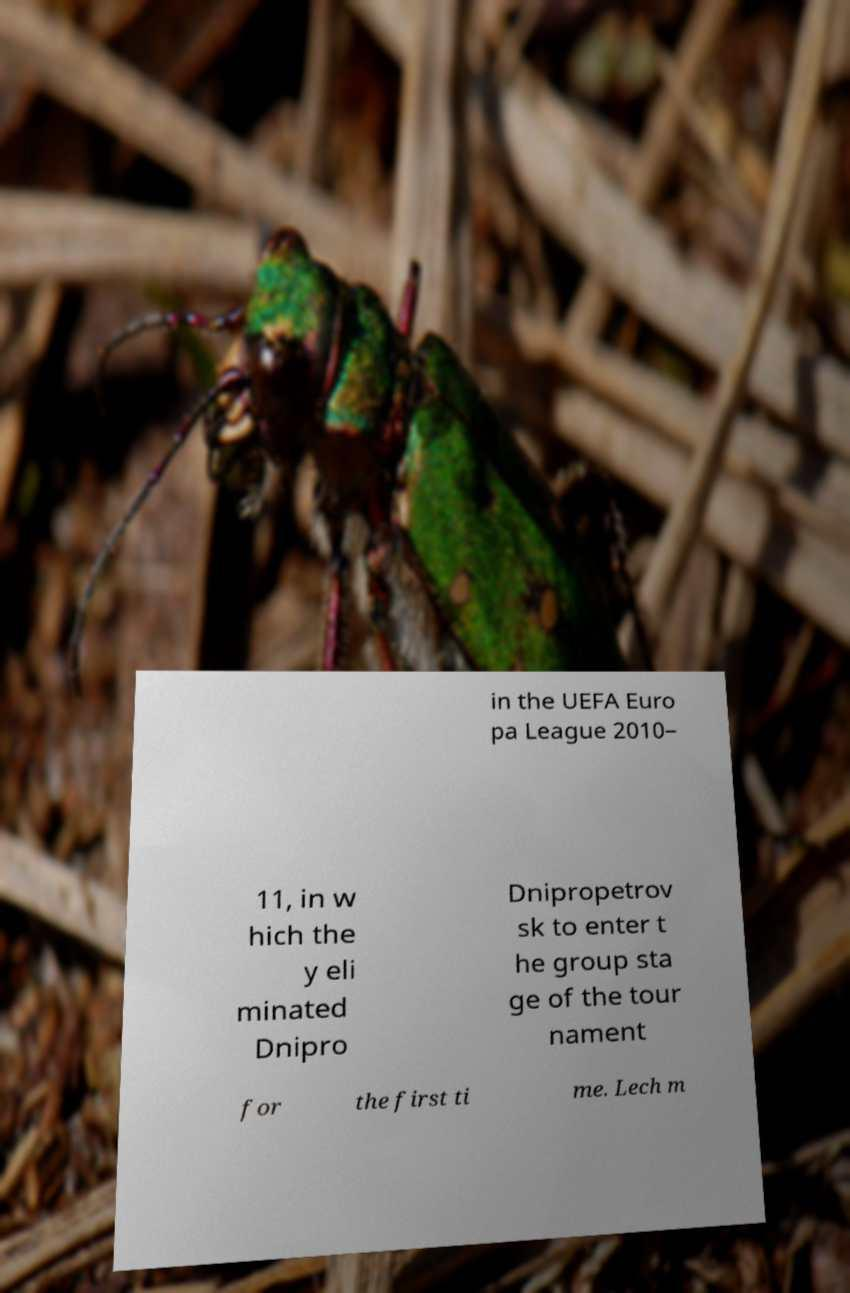Can you accurately transcribe the text from the provided image for me? in the UEFA Euro pa League 2010– 11, in w hich the y eli minated Dnipro Dnipropetrov sk to enter t he group sta ge of the tour nament for the first ti me. Lech m 